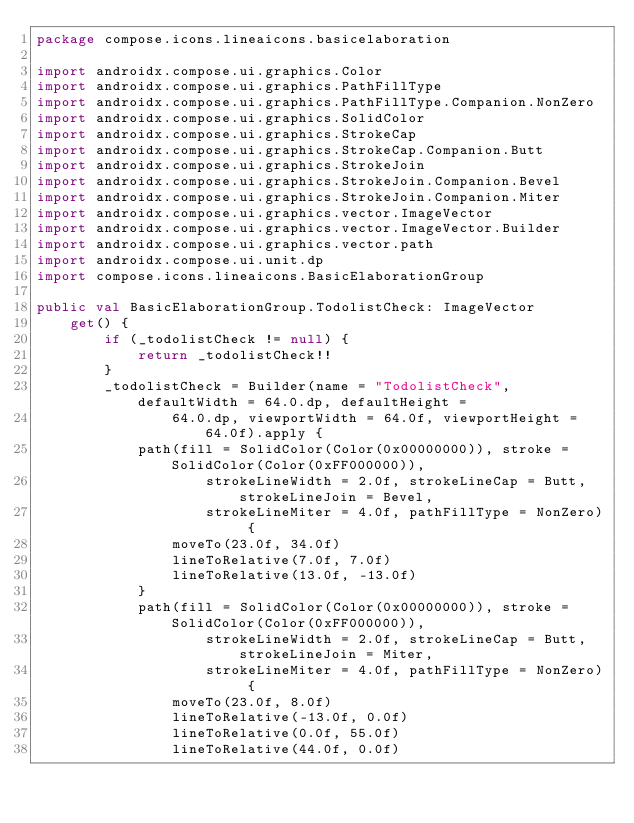<code> <loc_0><loc_0><loc_500><loc_500><_Kotlin_>package compose.icons.lineaicons.basicelaboration

import androidx.compose.ui.graphics.Color
import androidx.compose.ui.graphics.PathFillType
import androidx.compose.ui.graphics.PathFillType.Companion.NonZero
import androidx.compose.ui.graphics.SolidColor
import androidx.compose.ui.graphics.StrokeCap
import androidx.compose.ui.graphics.StrokeCap.Companion.Butt
import androidx.compose.ui.graphics.StrokeJoin
import androidx.compose.ui.graphics.StrokeJoin.Companion.Bevel
import androidx.compose.ui.graphics.StrokeJoin.Companion.Miter
import androidx.compose.ui.graphics.vector.ImageVector
import androidx.compose.ui.graphics.vector.ImageVector.Builder
import androidx.compose.ui.graphics.vector.path
import androidx.compose.ui.unit.dp
import compose.icons.lineaicons.BasicElaborationGroup

public val BasicElaborationGroup.TodolistCheck: ImageVector
    get() {
        if (_todolistCheck != null) {
            return _todolistCheck!!
        }
        _todolistCheck = Builder(name = "TodolistCheck", defaultWidth = 64.0.dp, defaultHeight =
                64.0.dp, viewportWidth = 64.0f, viewportHeight = 64.0f).apply {
            path(fill = SolidColor(Color(0x00000000)), stroke = SolidColor(Color(0xFF000000)),
                    strokeLineWidth = 2.0f, strokeLineCap = Butt, strokeLineJoin = Bevel,
                    strokeLineMiter = 4.0f, pathFillType = NonZero) {
                moveTo(23.0f, 34.0f)
                lineToRelative(7.0f, 7.0f)
                lineToRelative(13.0f, -13.0f)
            }
            path(fill = SolidColor(Color(0x00000000)), stroke = SolidColor(Color(0xFF000000)),
                    strokeLineWidth = 2.0f, strokeLineCap = Butt, strokeLineJoin = Miter,
                    strokeLineMiter = 4.0f, pathFillType = NonZero) {
                moveTo(23.0f, 8.0f)
                lineToRelative(-13.0f, 0.0f)
                lineToRelative(0.0f, 55.0f)
                lineToRelative(44.0f, 0.0f)</code> 